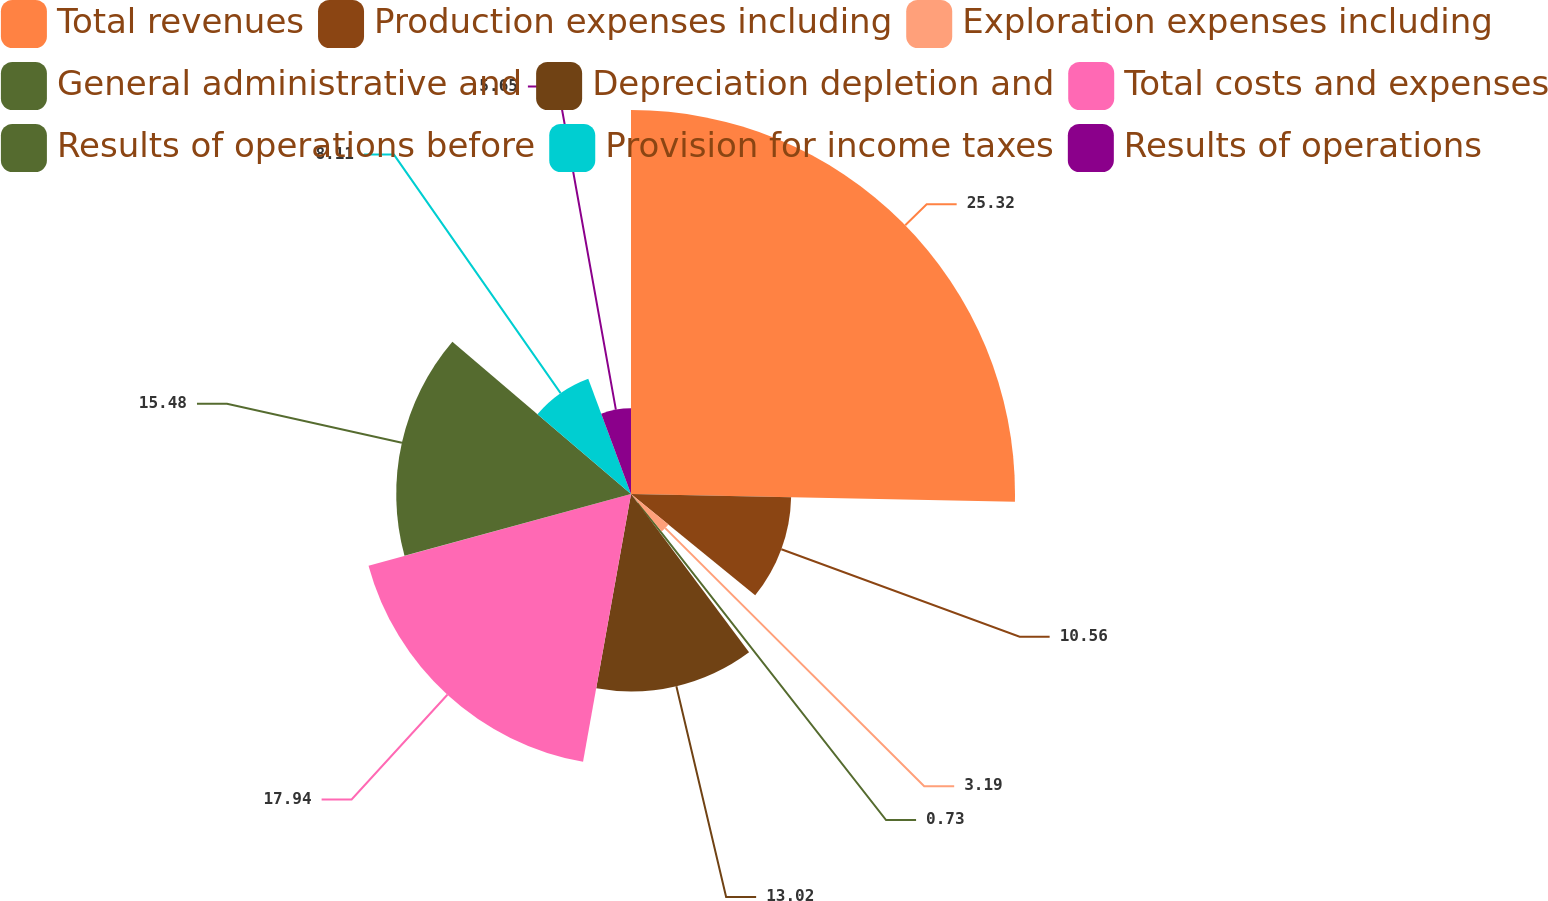<chart> <loc_0><loc_0><loc_500><loc_500><pie_chart><fcel>Total revenues<fcel>Production expenses including<fcel>Exploration expenses including<fcel>General administrative and<fcel>Depreciation depletion and<fcel>Total costs and expenses<fcel>Results of operations before<fcel>Provision for income taxes<fcel>Results of operations<nl><fcel>25.32%<fcel>10.56%<fcel>3.19%<fcel>0.73%<fcel>13.02%<fcel>17.94%<fcel>15.48%<fcel>8.11%<fcel>5.65%<nl></chart> 